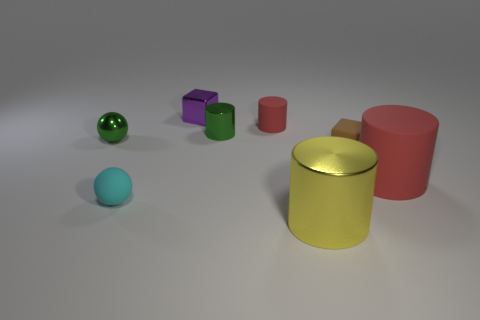Do the matte cylinder in front of the brown matte object and the tiny rubber cylinder have the same color?
Offer a very short reply. Yes. Are there any metallic things behind the large red matte thing?
Your answer should be compact. Yes. There is a thing that is to the left of the big yellow object and in front of the large matte cylinder; what is its color?
Provide a short and direct response. Cyan. What shape is the small shiny object that is the same color as the tiny metal ball?
Offer a very short reply. Cylinder. How big is the rubber cylinder behind the block that is to the right of the yellow metallic cylinder?
Keep it short and to the point. Small. What number of cubes are green things or yellow objects?
Give a very brief answer. 0. There is another cylinder that is the same size as the green cylinder; what color is it?
Give a very brief answer. Red. There is a small matte object that is in front of the red cylinder on the right side of the brown cube; what shape is it?
Ensure brevity in your answer.  Sphere. Does the green metallic object right of the purple metal thing have the same size as the large rubber object?
Your answer should be very brief. No. What number of other things are there of the same material as the large red thing
Your answer should be compact. 3. 